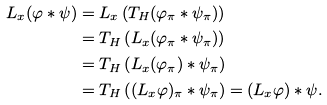<formula> <loc_0><loc_0><loc_500><loc_500>L _ { x } ( \varphi \ast \psi ) & = L _ { x } \left ( T _ { H } ( \varphi _ { \pi } \ast \psi _ { \pi } ) \right ) \\ & = T _ { H } \left ( L _ { x } ( \varphi _ { \pi } \ast \psi _ { \pi } ) \right ) \\ & = T _ { H } \left ( L _ { x } ( \varphi _ { \pi } ) \ast \psi _ { \pi } \right ) \\ & = T _ { H } \left ( ( L _ { x } \varphi ) _ { \pi } \ast \psi _ { \pi } \right ) = ( L _ { x } \varphi ) \ast \psi .</formula> 